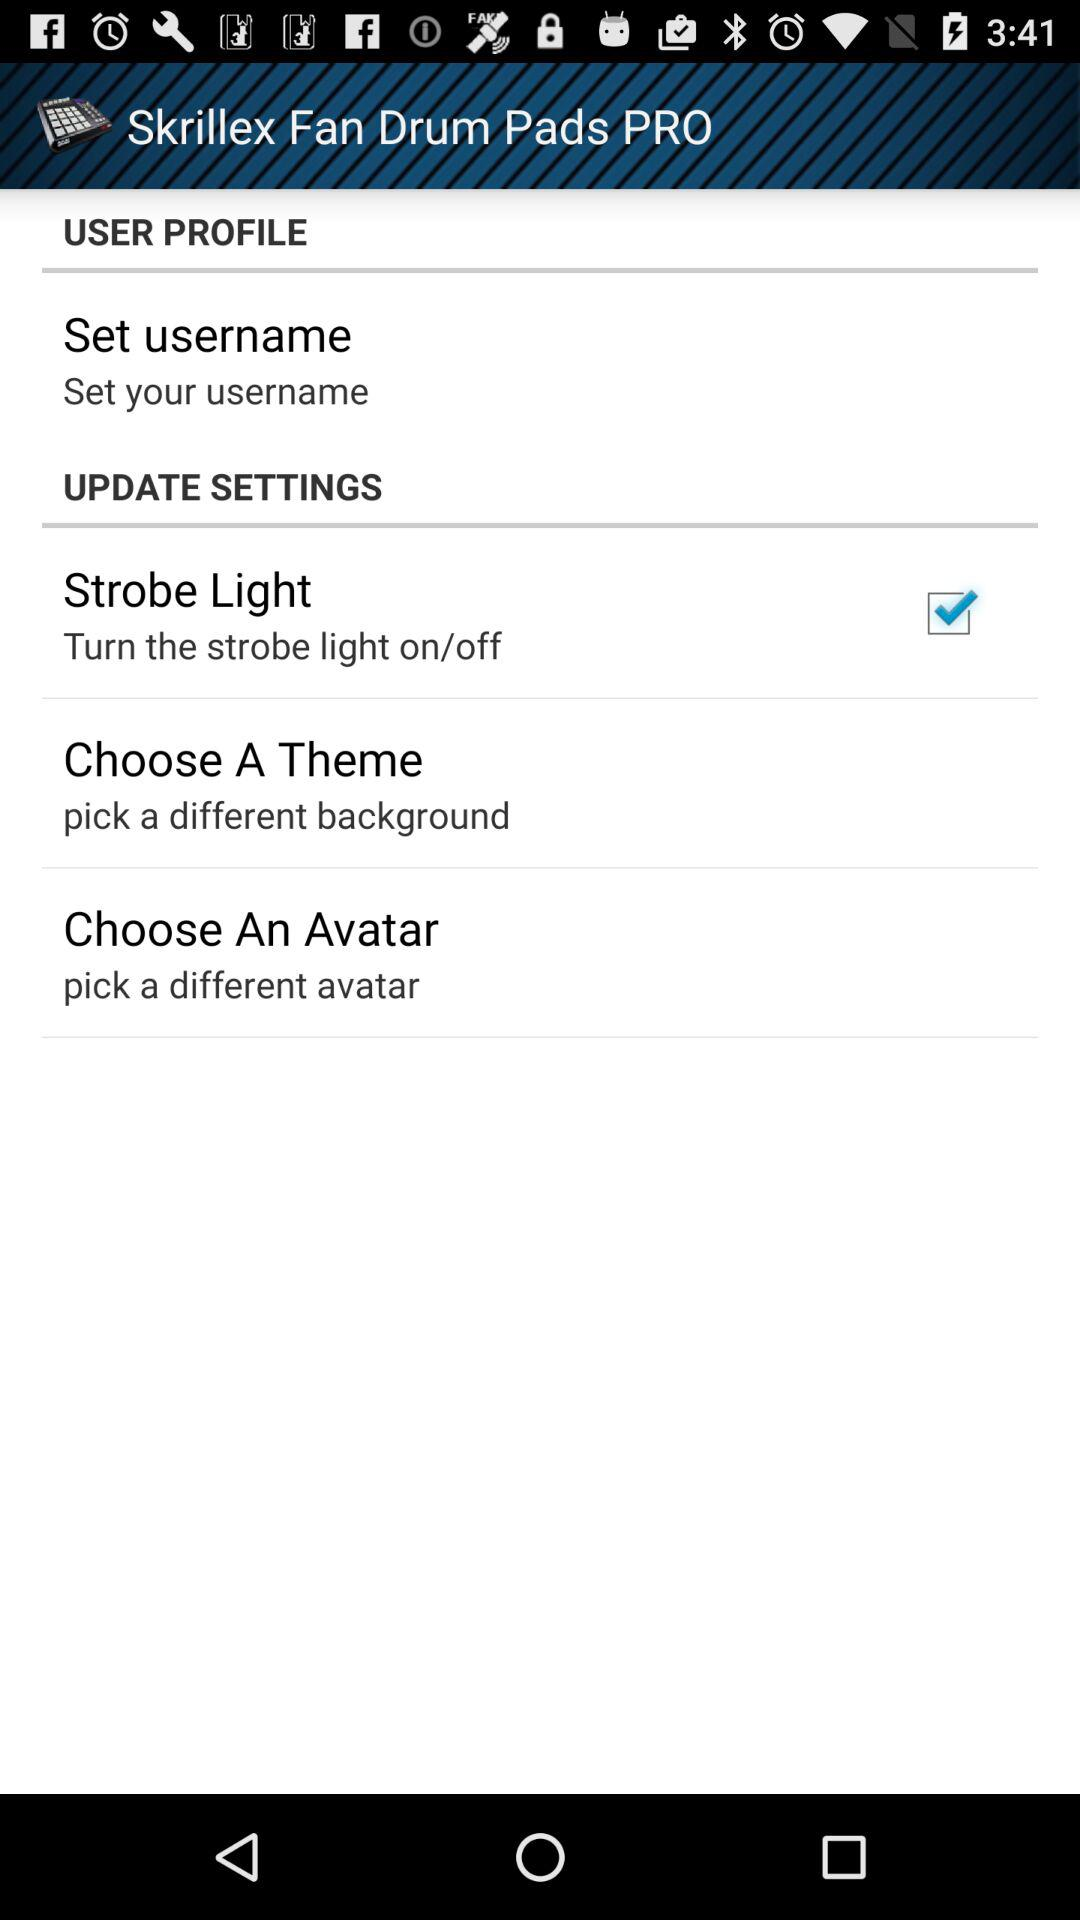What's the status of "Strobe Light"? The status is "on". 